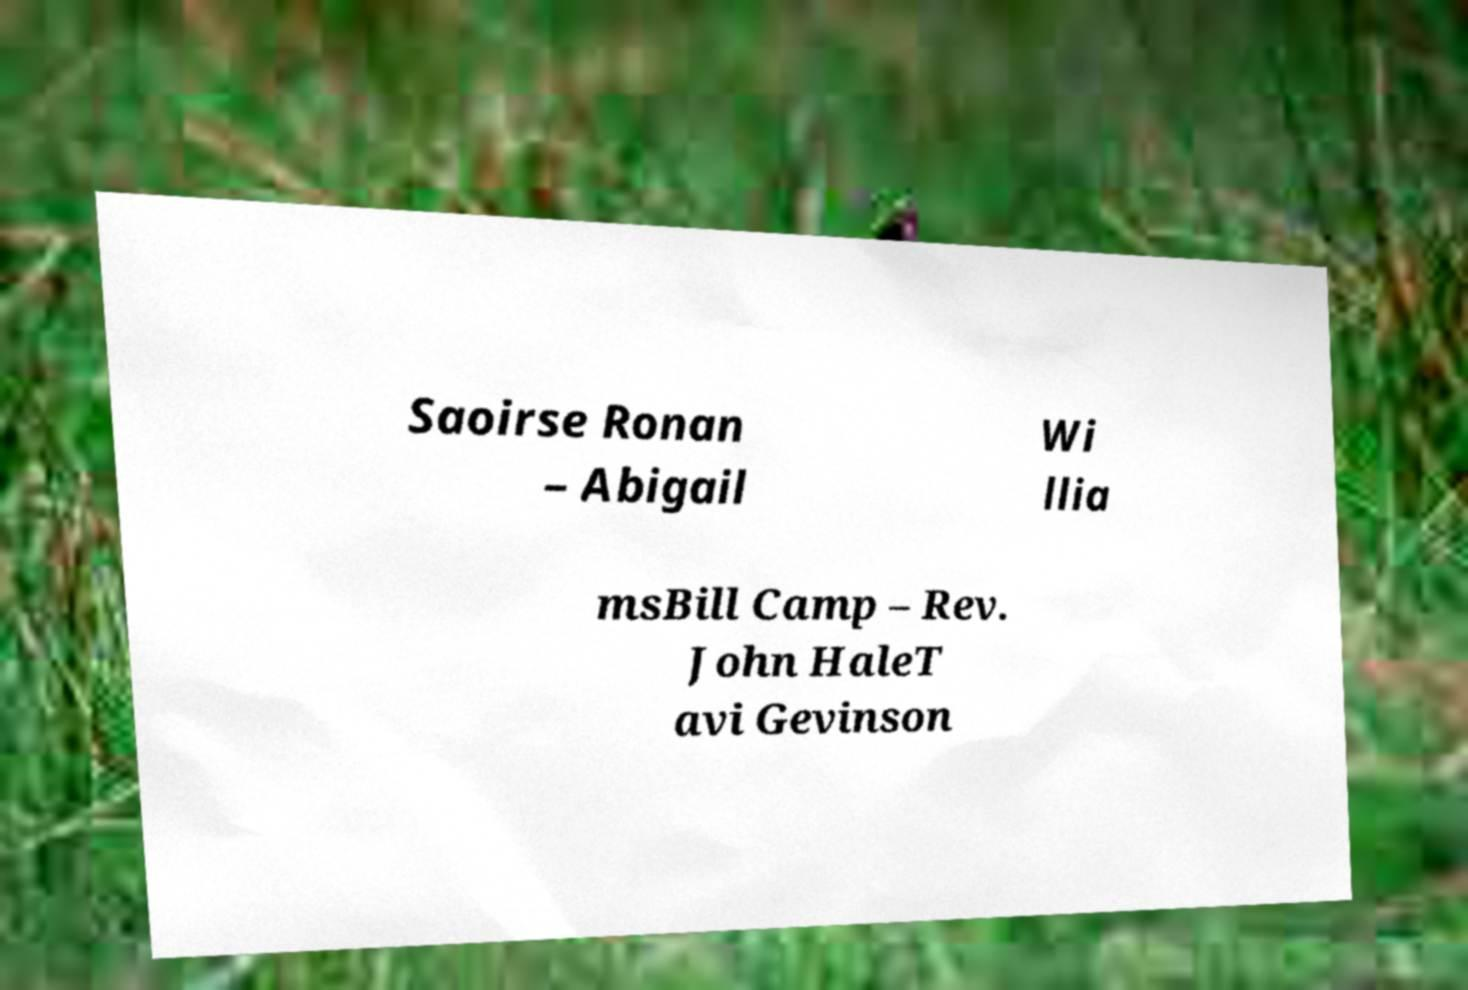For documentation purposes, I need the text within this image transcribed. Could you provide that? Saoirse Ronan – Abigail Wi llia msBill Camp – Rev. John HaleT avi Gevinson 